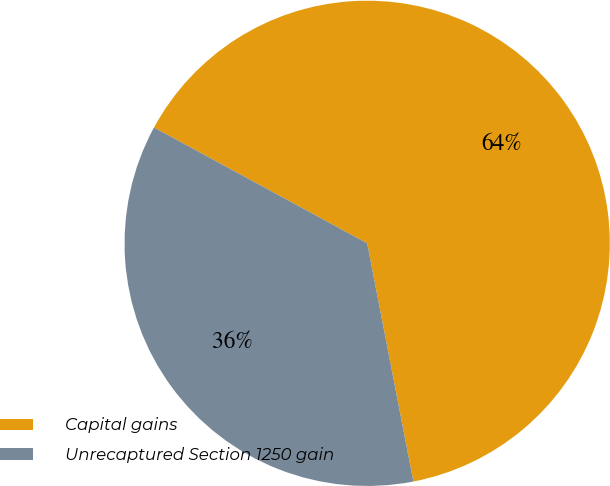Convert chart. <chart><loc_0><loc_0><loc_500><loc_500><pie_chart><fcel>Capital gains<fcel>Unrecaptured Section 1250 gain<nl><fcel>64.03%<fcel>35.97%<nl></chart> 